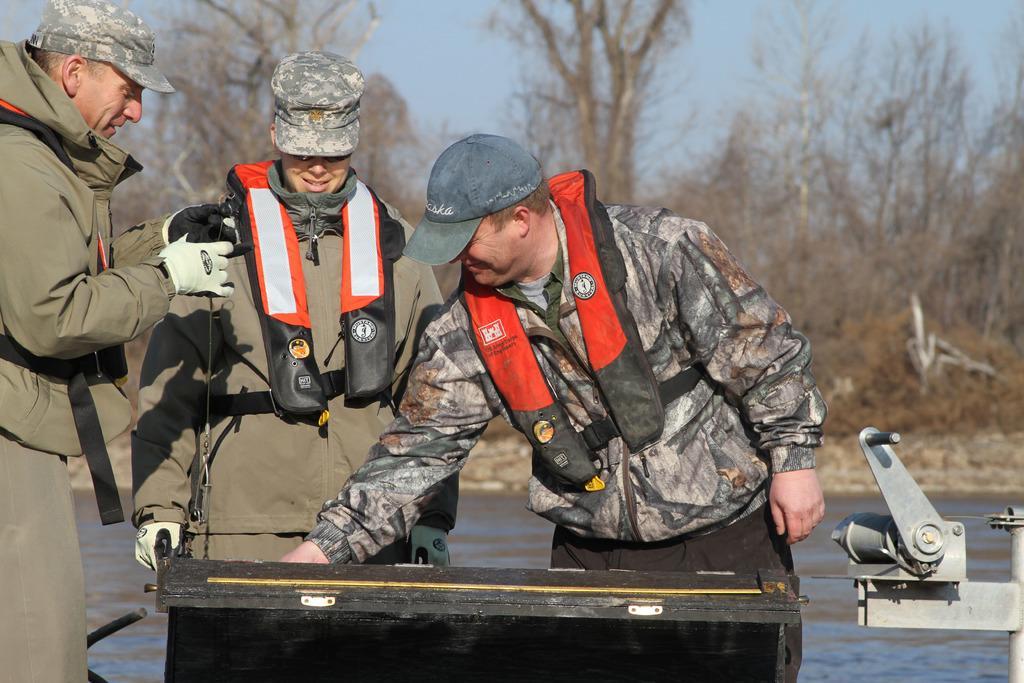How would you summarize this image in a sentence or two? In this picture we can see three men, they wore caps, behind them we can see water and few trees. 